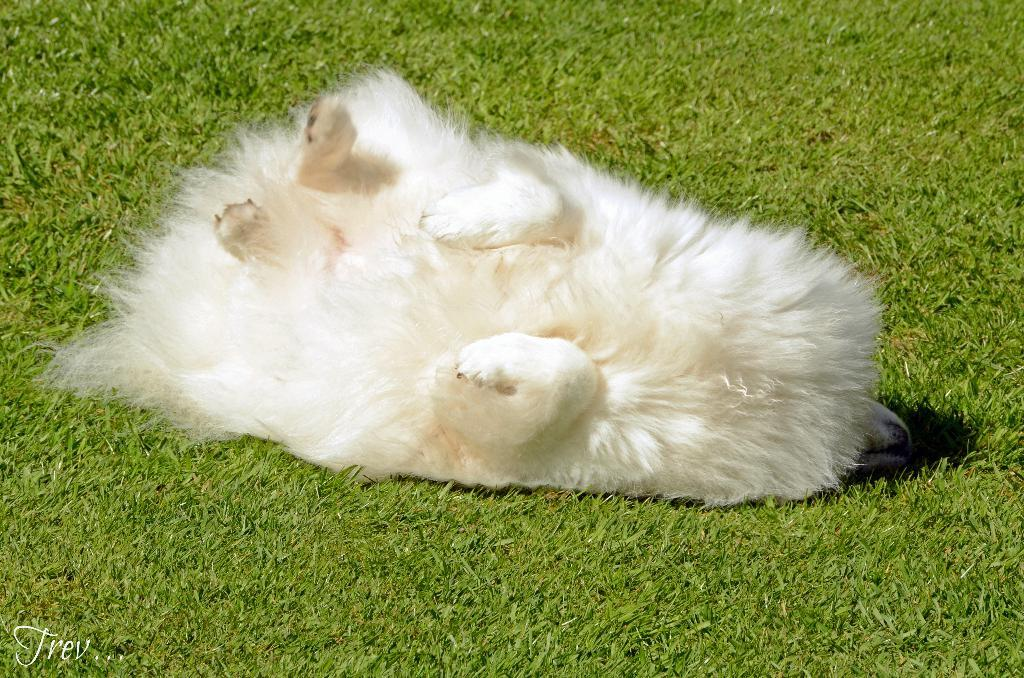What animal can be seen in the image? There is a dog in the image. Where is the dog located? The dog is on the surface of the grass. Is there any text present in the image? Yes, there is some text at the bottom left side of the image. What type of creature is the dog interacting with on the grass? There is no other creature present in the image; the dog is alone on the grass. What feeling does the dog seem to be experiencing in the image? The image does not convey any specific feelings or emotions of the dog, as it is a still image. 